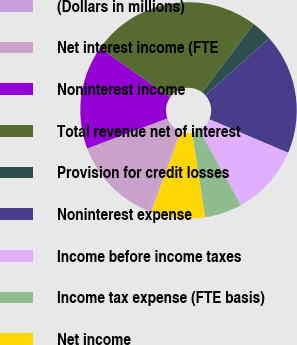Convert chart. <chart><loc_0><loc_0><loc_500><loc_500><pie_chart><fcel>(Dollars in millions)<fcel>Net interest income (FTE<fcel>Noninterest income<fcel>Total revenue net of interest<fcel>Provision for credit losses<fcel>Noninterest expense<fcel>Income before income taxes<fcel>Income tax expense (FTE basis)<fcel>Net income<nl><fcel>0.61%<fcel>13.05%<fcel>15.53%<fcel>25.48%<fcel>3.1%<fcel>18.02%<fcel>10.56%<fcel>5.59%<fcel>8.07%<nl></chart> 